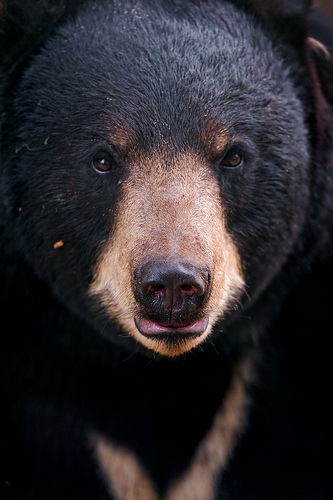Please provide a short description for this region: [0.39, 0.63, 0.61, 0.71]. The region highlighted by the coordinates [0.39, 0.63, 0.61, 0.71] depicts the bear's pink tongue. The color is vibrant and stands out against the darker and lighter furs around it. 